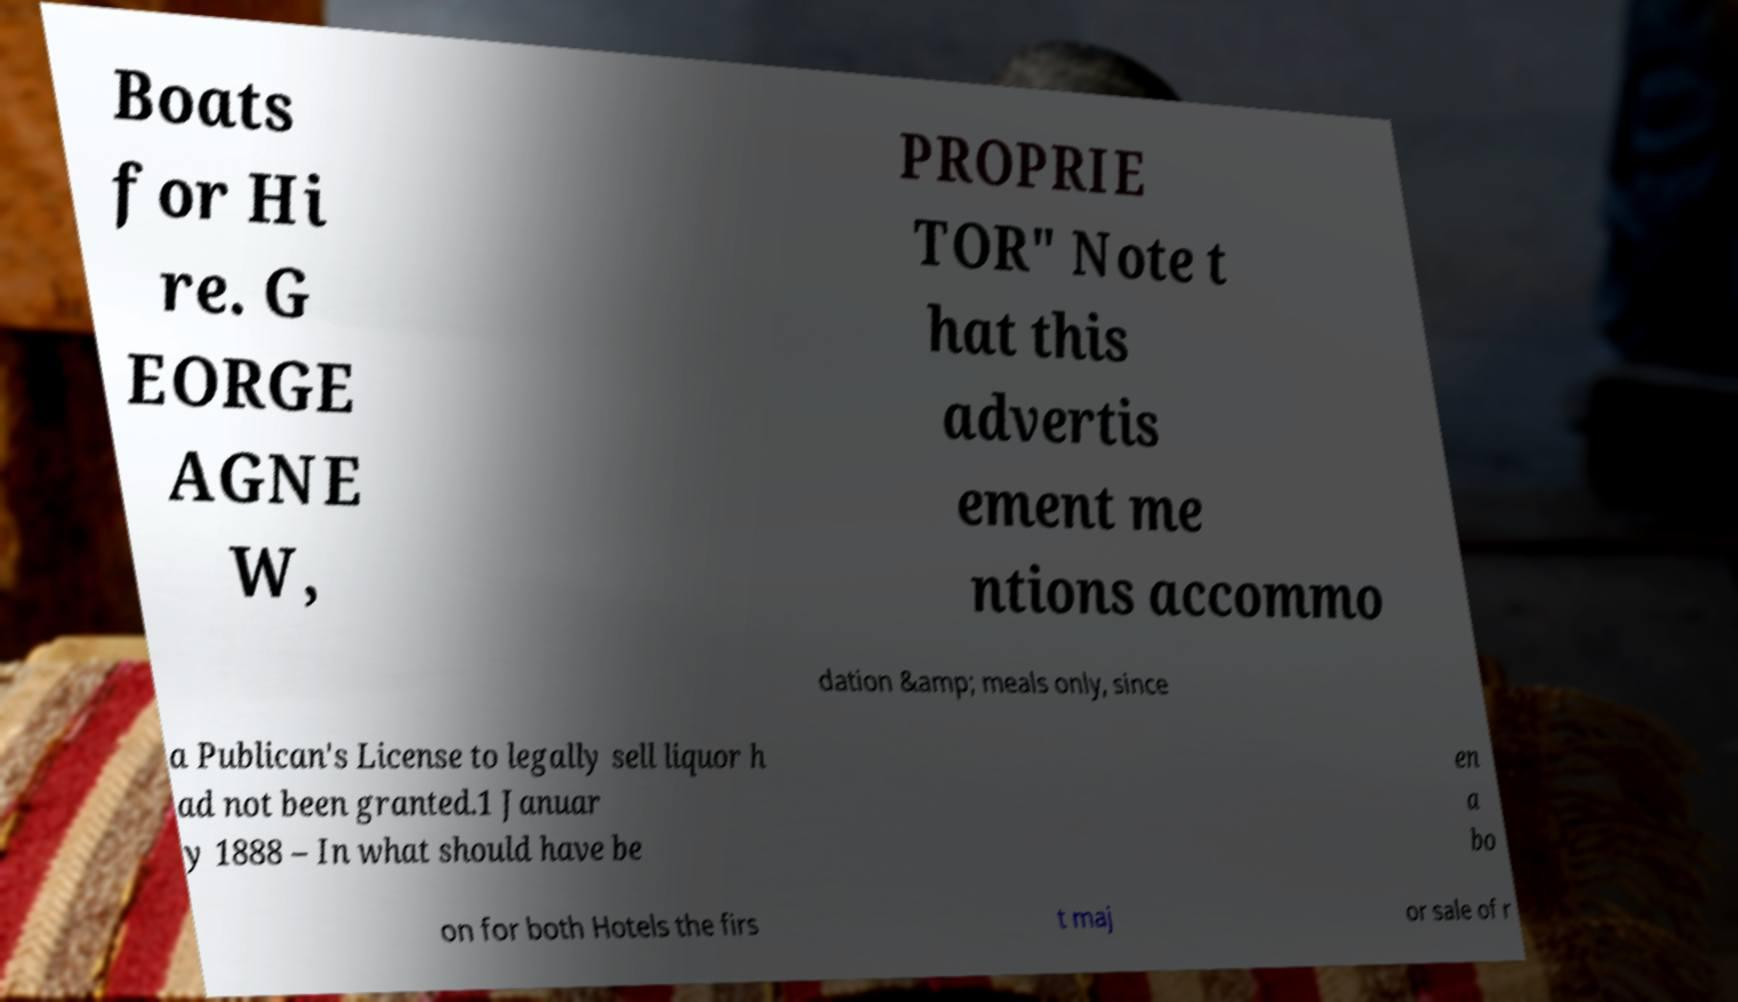Please identify and transcribe the text found in this image. Boats for Hi re. G EORGE AGNE W, PROPRIE TOR" Note t hat this advertis ement me ntions accommo dation &amp; meals only, since a Publican's License to legally sell liquor h ad not been granted.1 Januar y 1888 – In what should have be en a bo on for both Hotels the firs t maj or sale of r 